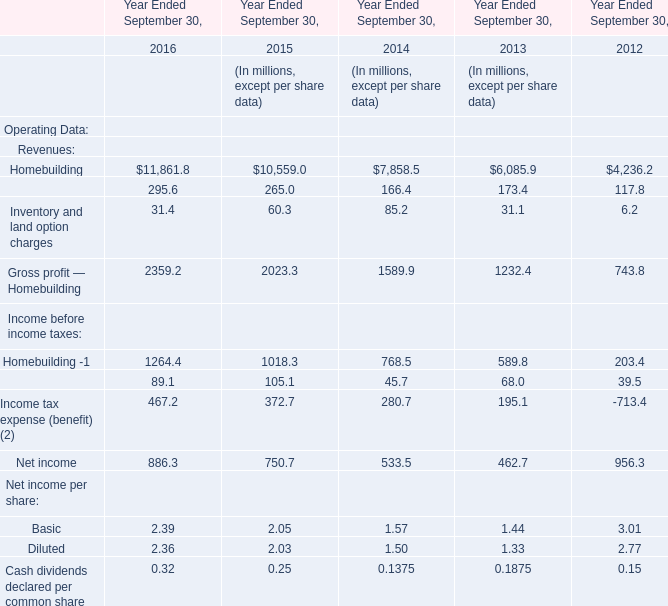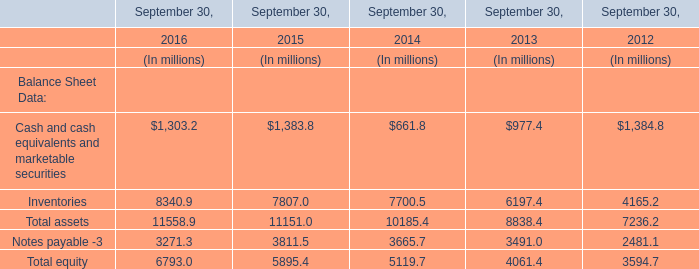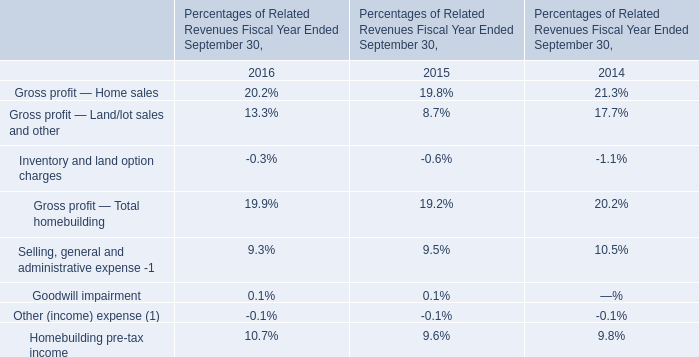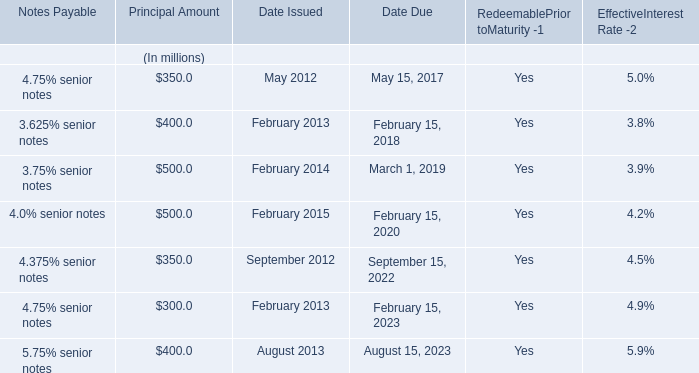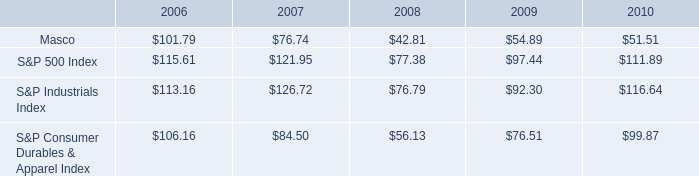In the year with the most Total equity, what is the growth rate of Cash and cash equivalents and marketable securities? 
Computations: ((1303.2 - 1383.8) / 1303.2)
Answer: -0.06185. 